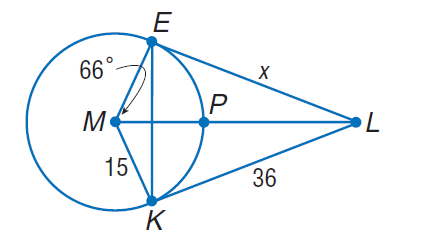Question: Find x. Assume that segments that appear to be tangent are tangent.
Choices:
A. 15
B. 21
C. 36
D. 72
Answer with the letter. Answer: C 